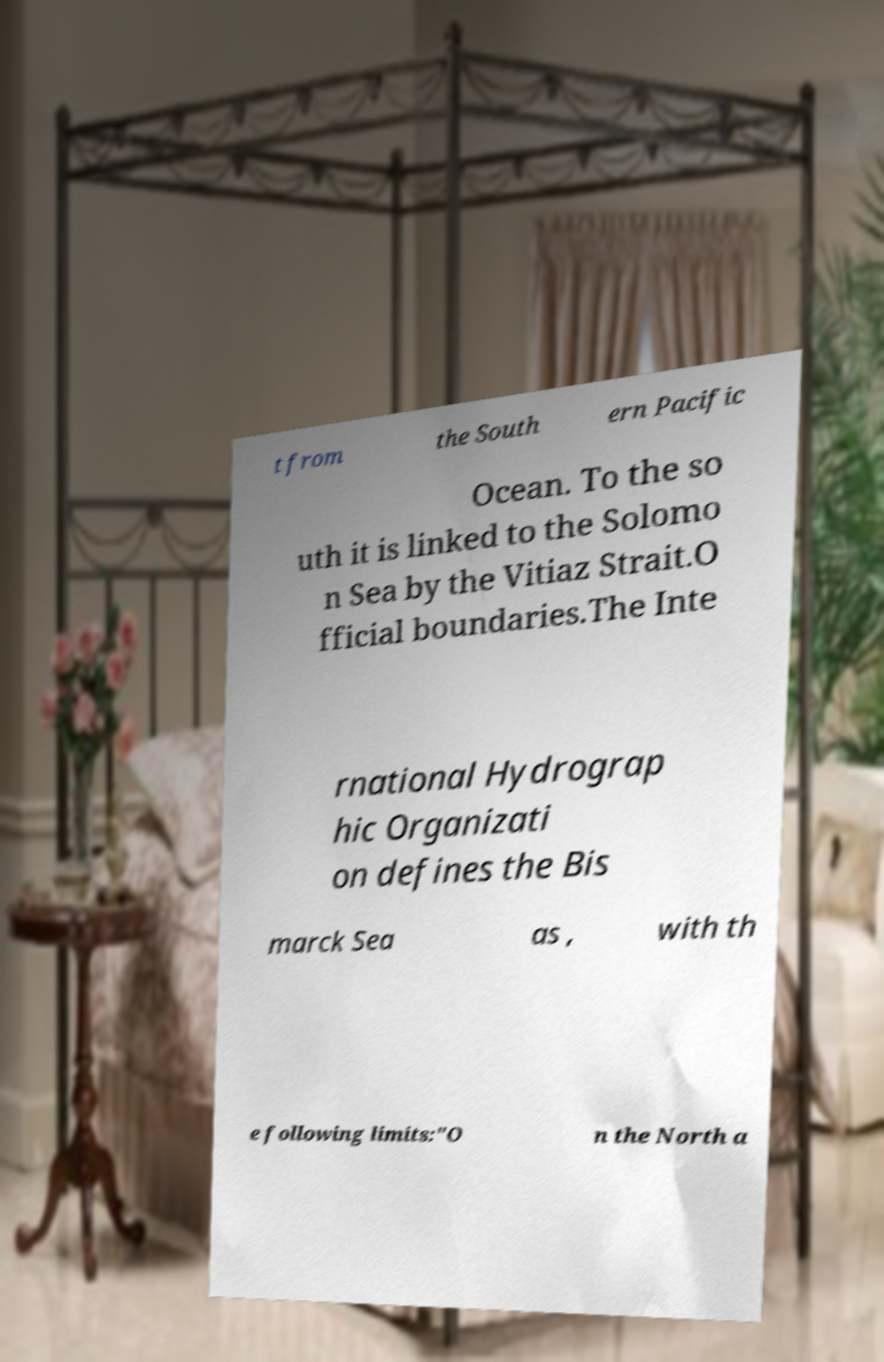What messages or text are displayed in this image? I need them in a readable, typed format. t from the South ern Pacific Ocean. To the so uth it is linked to the Solomo n Sea by the Vitiaz Strait.O fficial boundaries.The Inte rnational Hydrograp hic Organizati on defines the Bis marck Sea as , with th e following limits:"O n the North a 